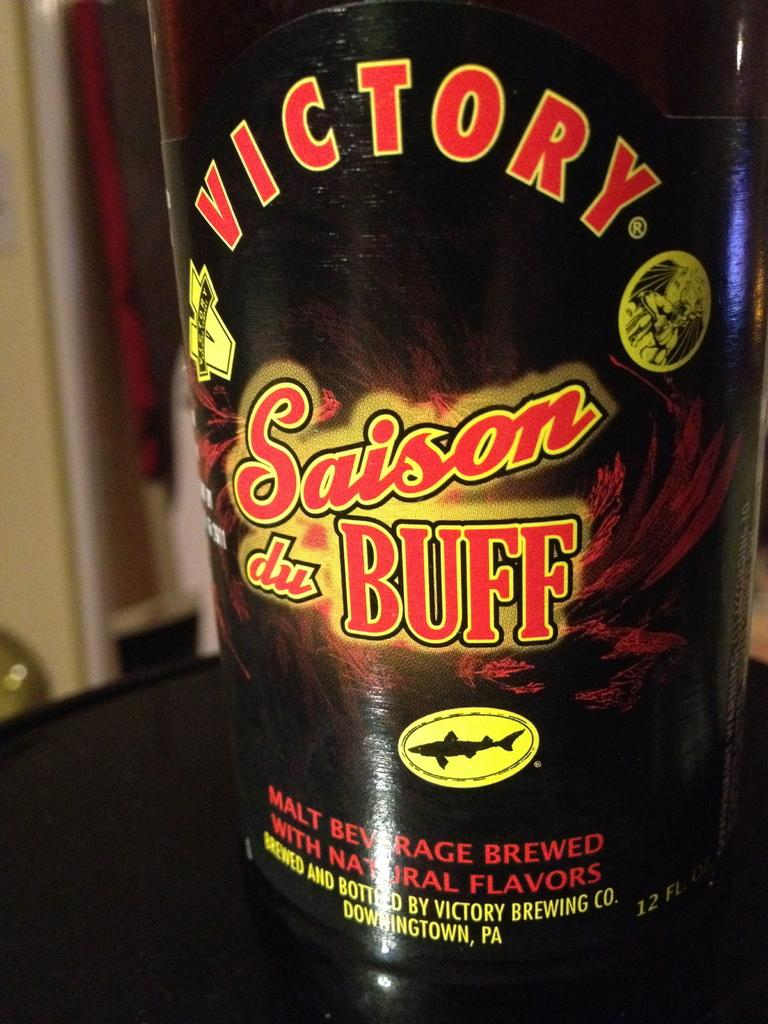<image>
Offer a succinct explanation of the picture presented. A bottle of malt beverage by Victory labeled Saison du buff. 